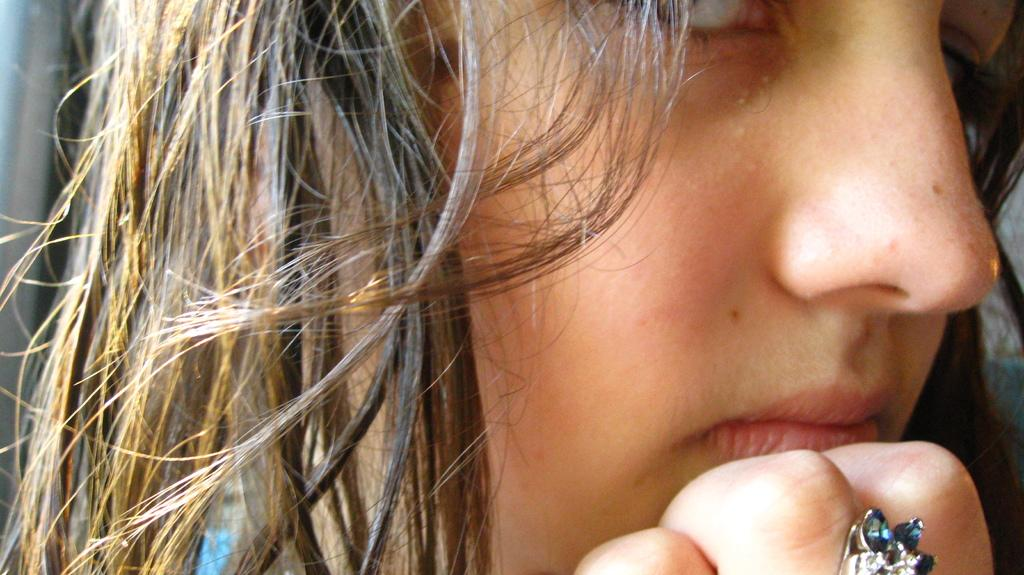Who is present in the image? There is a woman in the image. How many pies are being baked in the kettle by the woman in the image? There is no kettle or pies present in the image; it only features a woman. 